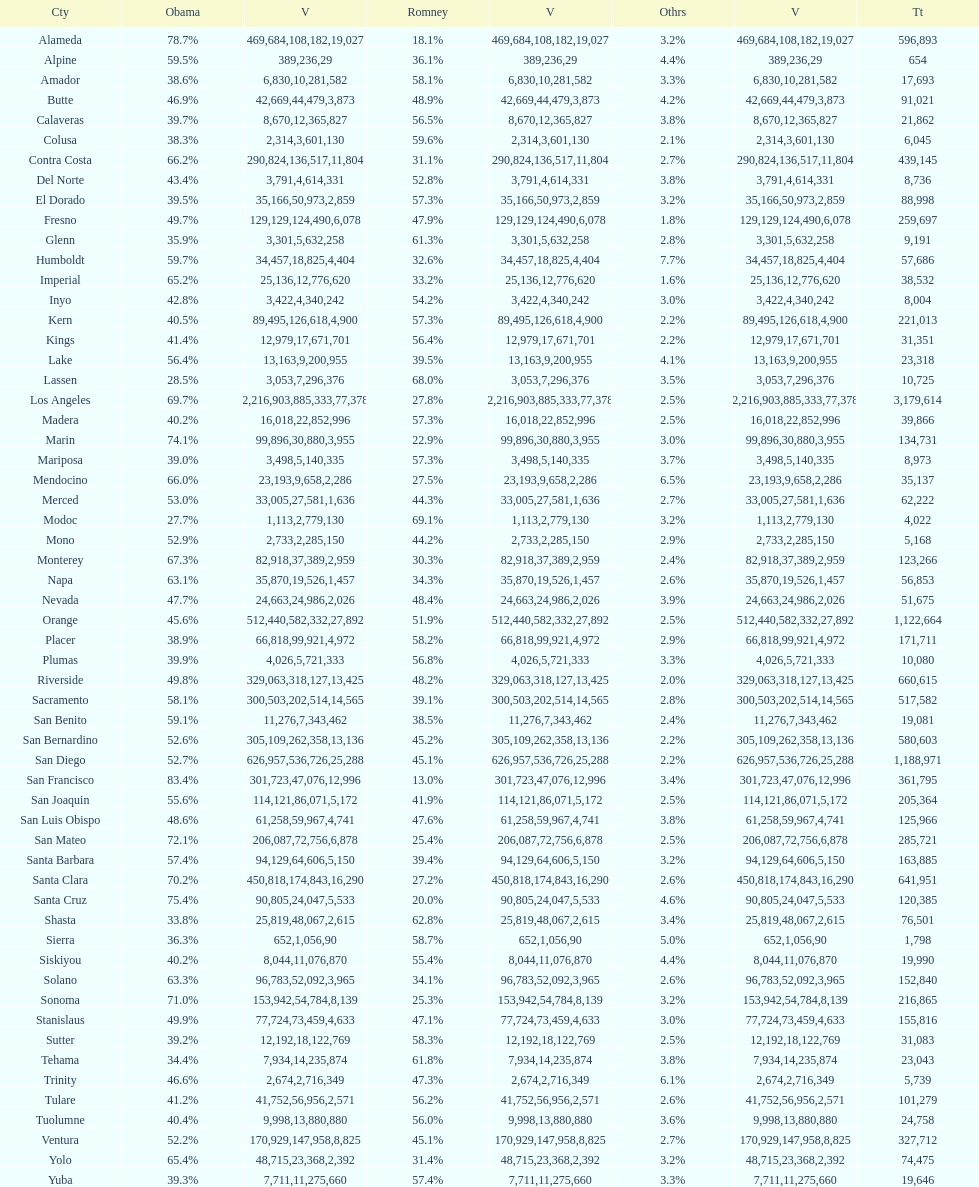Which county had the most total votes? Los Angeles. Could you help me parse every detail presented in this table? {'header': ['Cty', 'Obama', 'V', 'Romney', 'V', 'Othrs', 'V', 'Tt'], 'rows': [['Alameda', '78.7%', '469,684', '18.1%', '108,182', '3.2%', '19,027', '596,893'], ['Alpine', '59.5%', '389', '36.1%', '236', '4.4%', '29', '654'], ['Amador', '38.6%', '6,830', '58.1%', '10,281', '3.3%', '582', '17,693'], ['Butte', '46.9%', '42,669', '48.9%', '44,479', '4.2%', '3,873', '91,021'], ['Calaveras', '39.7%', '8,670', '56.5%', '12,365', '3.8%', '827', '21,862'], ['Colusa', '38.3%', '2,314', '59.6%', '3,601', '2.1%', '130', '6,045'], ['Contra Costa', '66.2%', '290,824', '31.1%', '136,517', '2.7%', '11,804', '439,145'], ['Del Norte', '43.4%', '3,791', '52.8%', '4,614', '3.8%', '331', '8,736'], ['El Dorado', '39.5%', '35,166', '57.3%', '50,973', '3.2%', '2,859', '88,998'], ['Fresno', '49.7%', '129,129', '47.9%', '124,490', '1.8%', '6,078', '259,697'], ['Glenn', '35.9%', '3,301', '61.3%', '5,632', '2.8%', '258', '9,191'], ['Humboldt', '59.7%', '34,457', '32.6%', '18,825', '7.7%', '4,404', '57,686'], ['Imperial', '65.2%', '25,136', '33.2%', '12,776', '1.6%', '620', '38,532'], ['Inyo', '42.8%', '3,422', '54.2%', '4,340', '3.0%', '242', '8,004'], ['Kern', '40.5%', '89,495', '57.3%', '126,618', '2.2%', '4,900', '221,013'], ['Kings', '41.4%', '12,979', '56.4%', '17,671', '2.2%', '701', '31,351'], ['Lake', '56.4%', '13,163', '39.5%', '9,200', '4.1%', '955', '23,318'], ['Lassen', '28.5%', '3,053', '68.0%', '7,296', '3.5%', '376', '10,725'], ['Los Angeles', '69.7%', '2,216,903', '27.8%', '885,333', '2.5%', '77,378', '3,179,614'], ['Madera', '40.2%', '16,018', '57.3%', '22,852', '2.5%', '996', '39,866'], ['Marin', '74.1%', '99,896', '22.9%', '30,880', '3.0%', '3,955', '134,731'], ['Mariposa', '39.0%', '3,498', '57.3%', '5,140', '3.7%', '335', '8,973'], ['Mendocino', '66.0%', '23,193', '27.5%', '9,658', '6.5%', '2,286', '35,137'], ['Merced', '53.0%', '33,005', '44.3%', '27,581', '2.7%', '1,636', '62,222'], ['Modoc', '27.7%', '1,113', '69.1%', '2,779', '3.2%', '130', '4,022'], ['Mono', '52.9%', '2,733', '44.2%', '2,285', '2.9%', '150', '5,168'], ['Monterey', '67.3%', '82,918', '30.3%', '37,389', '2.4%', '2,959', '123,266'], ['Napa', '63.1%', '35,870', '34.3%', '19,526', '2.6%', '1,457', '56,853'], ['Nevada', '47.7%', '24,663', '48.4%', '24,986', '3.9%', '2,026', '51,675'], ['Orange', '45.6%', '512,440', '51.9%', '582,332', '2.5%', '27,892', '1,122,664'], ['Placer', '38.9%', '66,818', '58.2%', '99,921', '2.9%', '4,972', '171,711'], ['Plumas', '39.9%', '4,026', '56.8%', '5,721', '3.3%', '333', '10,080'], ['Riverside', '49.8%', '329,063', '48.2%', '318,127', '2.0%', '13,425', '660,615'], ['Sacramento', '58.1%', '300,503', '39.1%', '202,514', '2.8%', '14,565', '517,582'], ['San Benito', '59.1%', '11,276', '38.5%', '7,343', '2.4%', '462', '19,081'], ['San Bernardino', '52.6%', '305,109', '45.2%', '262,358', '2.2%', '13,136', '580,603'], ['San Diego', '52.7%', '626,957', '45.1%', '536,726', '2.2%', '25,288', '1,188,971'], ['San Francisco', '83.4%', '301,723', '13.0%', '47,076', '3.4%', '12,996', '361,795'], ['San Joaquin', '55.6%', '114,121', '41.9%', '86,071', '2.5%', '5,172', '205,364'], ['San Luis Obispo', '48.6%', '61,258', '47.6%', '59,967', '3.8%', '4,741', '125,966'], ['San Mateo', '72.1%', '206,087', '25.4%', '72,756', '2.5%', '6,878', '285,721'], ['Santa Barbara', '57.4%', '94,129', '39.4%', '64,606', '3.2%', '5,150', '163,885'], ['Santa Clara', '70.2%', '450,818', '27.2%', '174,843', '2.6%', '16,290', '641,951'], ['Santa Cruz', '75.4%', '90,805', '20.0%', '24,047', '4.6%', '5,533', '120,385'], ['Shasta', '33.8%', '25,819', '62.8%', '48,067', '3.4%', '2,615', '76,501'], ['Sierra', '36.3%', '652', '58.7%', '1,056', '5.0%', '90', '1,798'], ['Siskiyou', '40.2%', '8,044', '55.4%', '11,076', '4.4%', '870', '19,990'], ['Solano', '63.3%', '96,783', '34.1%', '52,092', '2.6%', '3,965', '152,840'], ['Sonoma', '71.0%', '153,942', '25.3%', '54,784', '3.2%', '8,139', '216,865'], ['Stanislaus', '49.9%', '77,724', '47.1%', '73,459', '3.0%', '4,633', '155,816'], ['Sutter', '39.2%', '12,192', '58.3%', '18,122', '2.5%', '769', '31,083'], ['Tehama', '34.4%', '7,934', '61.8%', '14,235', '3.8%', '874', '23,043'], ['Trinity', '46.6%', '2,674', '47.3%', '2,716', '6.1%', '349', '5,739'], ['Tulare', '41.2%', '41,752', '56.2%', '56,956', '2.6%', '2,571', '101,279'], ['Tuolumne', '40.4%', '9,998', '56.0%', '13,880', '3.6%', '880', '24,758'], ['Ventura', '52.2%', '170,929', '45.1%', '147,958', '2.7%', '8,825', '327,712'], ['Yolo', '65.4%', '48,715', '31.4%', '23,368', '3.2%', '2,392', '74,475'], ['Yuba', '39.3%', '7,711', '57.4%', '11,275', '3.3%', '660', '19,646']]} 